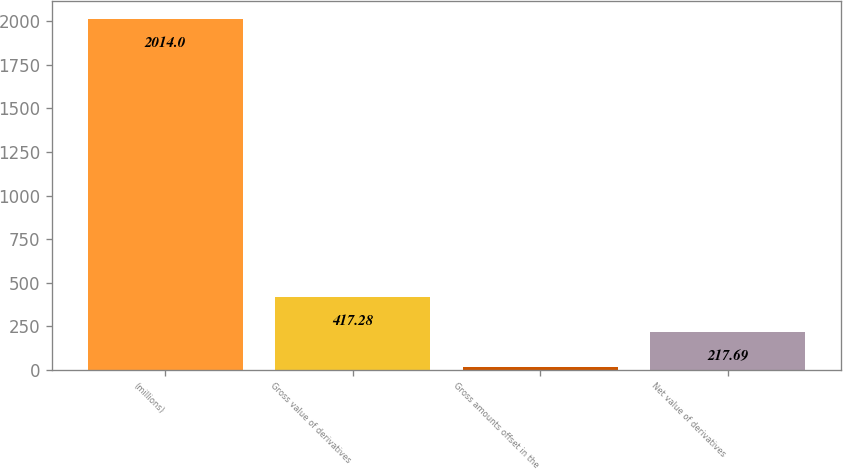<chart> <loc_0><loc_0><loc_500><loc_500><bar_chart><fcel>(millions)<fcel>Gross value of derivatives<fcel>Gross amounts offset in the<fcel>Net value of derivatives<nl><fcel>2014<fcel>417.28<fcel>18.1<fcel>217.69<nl></chart> 